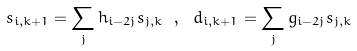<formula> <loc_0><loc_0><loc_500><loc_500>s _ { i , k + 1 } = \sum _ { j } h _ { i - 2 j } s _ { j , k } \ , \ d _ { i , k + 1 } = \sum _ { j } g _ { i - 2 j } s _ { j , k }</formula> 